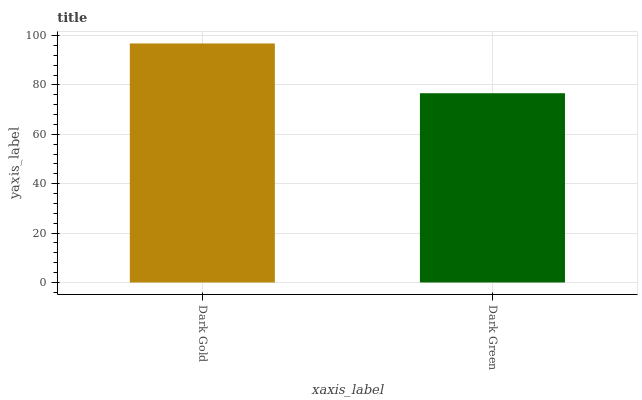Is Dark Green the minimum?
Answer yes or no. Yes. Is Dark Gold the maximum?
Answer yes or no. Yes. Is Dark Green the maximum?
Answer yes or no. No. Is Dark Gold greater than Dark Green?
Answer yes or no. Yes. Is Dark Green less than Dark Gold?
Answer yes or no. Yes. Is Dark Green greater than Dark Gold?
Answer yes or no. No. Is Dark Gold less than Dark Green?
Answer yes or no. No. Is Dark Gold the high median?
Answer yes or no. Yes. Is Dark Green the low median?
Answer yes or no. Yes. Is Dark Green the high median?
Answer yes or no. No. Is Dark Gold the low median?
Answer yes or no. No. 